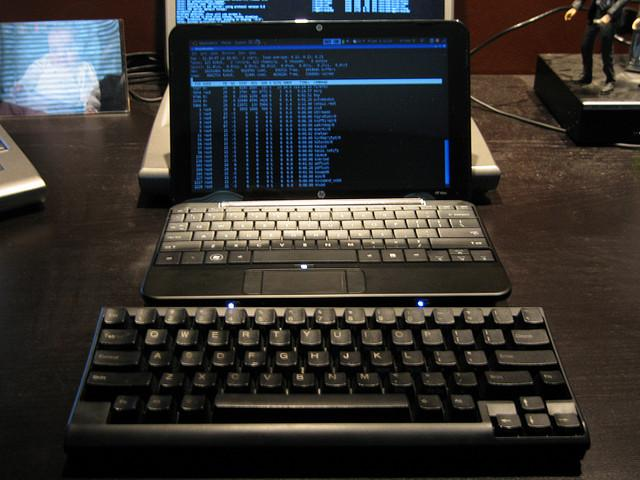Based on what's shown on the computer screen what is this person doing? Please explain your reasoning. programming. There appears to be lines of code on the computer which is something a person doing answer a might encounter. 